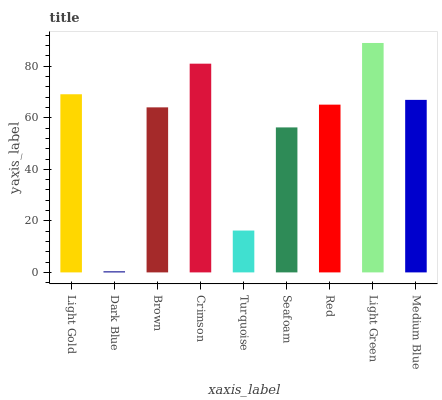Is Brown the minimum?
Answer yes or no. No. Is Brown the maximum?
Answer yes or no. No. Is Brown greater than Dark Blue?
Answer yes or no. Yes. Is Dark Blue less than Brown?
Answer yes or no. Yes. Is Dark Blue greater than Brown?
Answer yes or no. No. Is Brown less than Dark Blue?
Answer yes or no. No. Is Red the high median?
Answer yes or no. Yes. Is Red the low median?
Answer yes or no. Yes. Is Light Gold the high median?
Answer yes or no. No. Is Turquoise the low median?
Answer yes or no. No. 